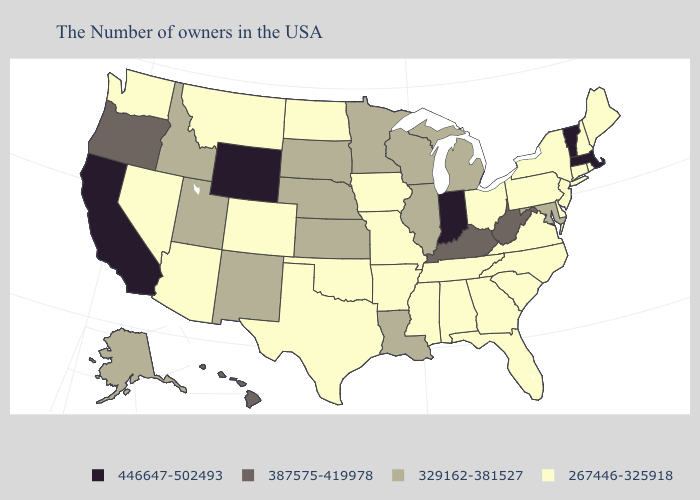Name the states that have a value in the range 446647-502493?
Be succinct. Massachusetts, Vermont, Indiana, Wyoming, California. Among the states that border Alabama , which have the highest value?
Short answer required. Florida, Georgia, Tennessee, Mississippi. What is the highest value in the Northeast ?
Concise answer only. 446647-502493. Name the states that have a value in the range 387575-419978?
Keep it brief. West Virginia, Kentucky, Oregon, Hawaii. How many symbols are there in the legend?
Give a very brief answer. 4. How many symbols are there in the legend?
Quick response, please. 4. Name the states that have a value in the range 267446-325918?
Give a very brief answer. Maine, Rhode Island, New Hampshire, Connecticut, New York, New Jersey, Delaware, Pennsylvania, Virginia, North Carolina, South Carolina, Ohio, Florida, Georgia, Alabama, Tennessee, Mississippi, Missouri, Arkansas, Iowa, Oklahoma, Texas, North Dakota, Colorado, Montana, Arizona, Nevada, Washington. How many symbols are there in the legend?
Give a very brief answer. 4. Which states hav the highest value in the Northeast?
Keep it brief. Massachusetts, Vermont. Does the first symbol in the legend represent the smallest category?
Concise answer only. No. Does Delaware have a lower value than Illinois?
Quick response, please. Yes. Name the states that have a value in the range 446647-502493?
Keep it brief. Massachusetts, Vermont, Indiana, Wyoming, California. Does Alaska have the lowest value in the West?
Give a very brief answer. No. Among the states that border Indiana , which have the highest value?
Give a very brief answer. Kentucky. Does Massachusetts have the lowest value in the Northeast?
Be succinct. No. 